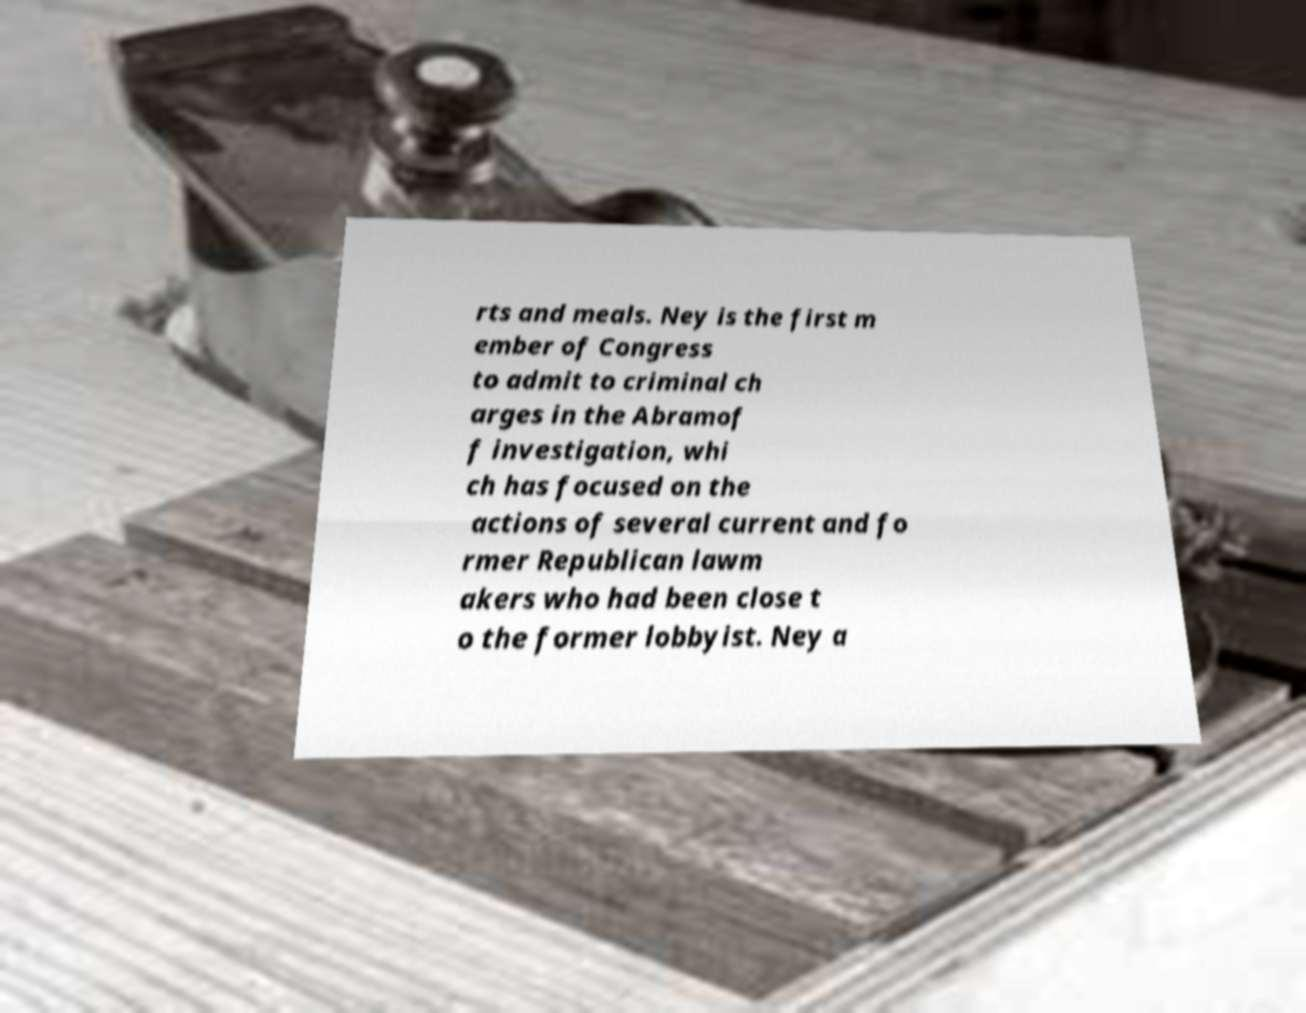What messages or text are displayed in this image? I need them in a readable, typed format. rts and meals. Ney is the first m ember of Congress to admit to criminal ch arges in the Abramof f investigation, whi ch has focused on the actions of several current and fo rmer Republican lawm akers who had been close t o the former lobbyist. Ney a 